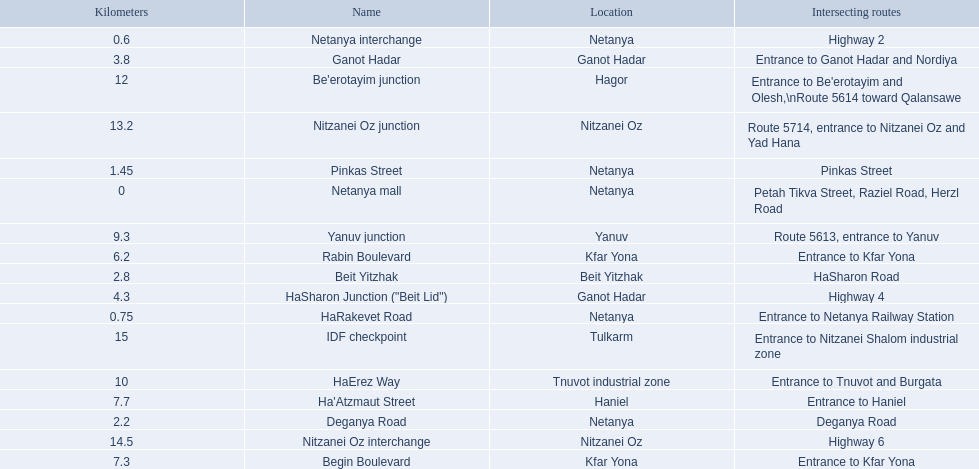What are all the names? Netanya mall, Netanya interchange, HaRakevet Road, Pinkas Street, Deganya Road, Beit Yitzhak, Ganot Hadar, HaSharon Junction ("Beit Lid"), Rabin Boulevard, Begin Boulevard, Ha'Atzmaut Street, Yanuv junction, HaErez Way, Be'erotayim junction, Nitzanei Oz junction, Nitzanei Oz interchange, IDF checkpoint. Where do they intersect? Petah Tikva Street, Raziel Road, Herzl Road, Highway 2, Entrance to Netanya Railway Station, Pinkas Street, Deganya Road, HaSharon Road, Entrance to Ganot Hadar and Nordiya, Highway 4, Entrance to Kfar Yona, Entrance to Kfar Yona, Entrance to Haniel, Route 5613, entrance to Yanuv, Entrance to Tnuvot and Burgata, Entrance to Be'erotayim and Olesh,\nRoute 5614 toward Qalansawe, Route 5714, entrance to Nitzanei Oz and Yad Hana, Highway 6, Entrance to Nitzanei Shalom industrial zone. And which shares an intersection with rabin boulevard? Begin Boulevard. 